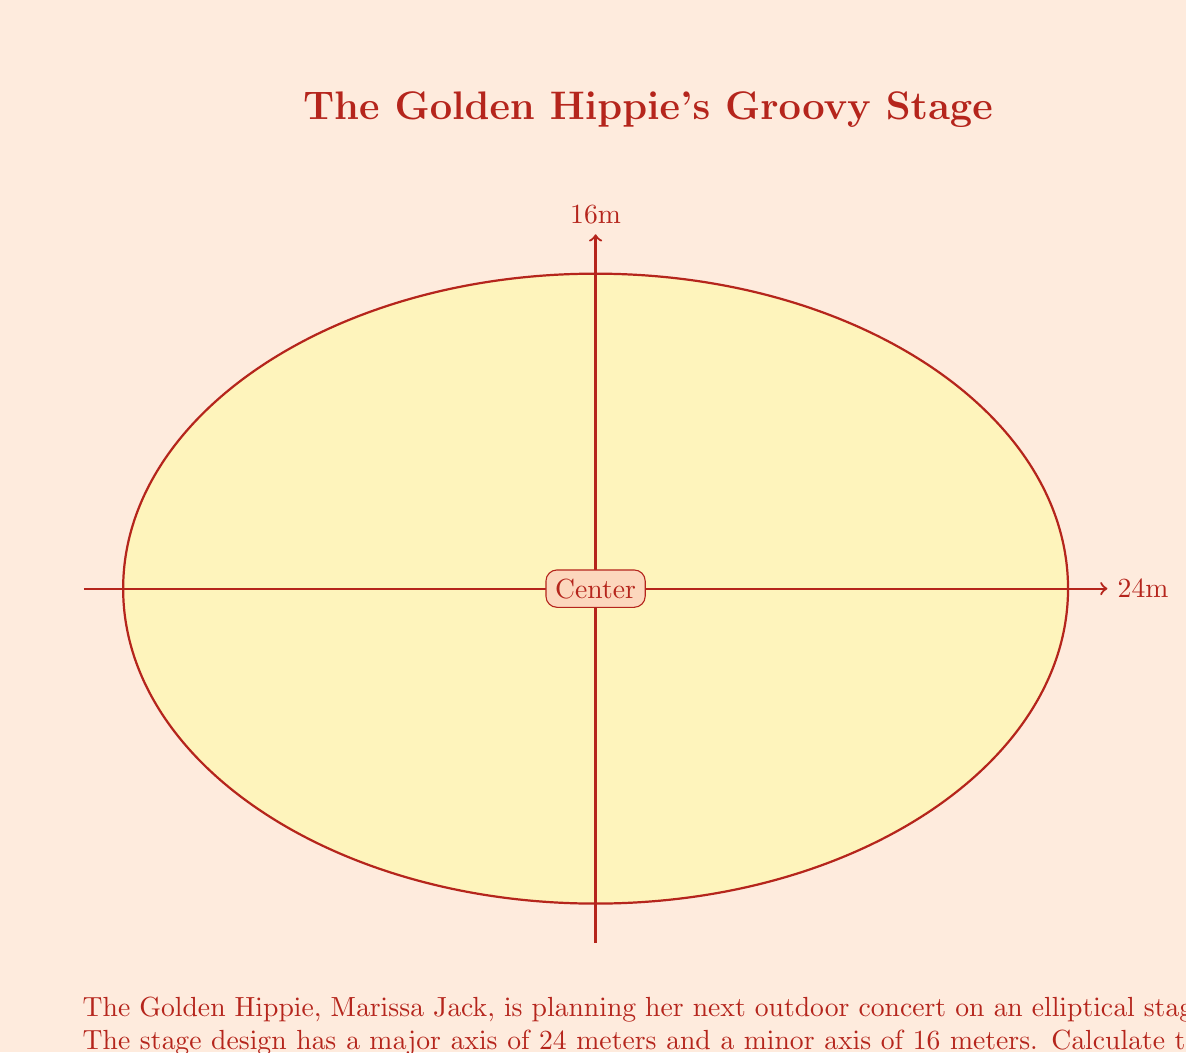Can you answer this question? Let's groove through this calculation step by step:

1) The formula for the area of an ellipse is:

   $$A = \pi ab$$

   where $a$ is half the length of the major axis and $b$ is half the length of the minor axis.

2) From the given dimensions:
   - Major axis = 24 meters, so $a = 24/2 = 12$ meters
   - Minor axis = 16 meters, so $b = 16/2 = 8$ meters

3) Now, let's plug these values into our formula:

   $$A = \pi (12)(8)$$

4) Simplify:
   $$A = 96\pi$$

5) If we want to express this in square meters (to two decimal places):
   $$A \approx 301.59 \text{ m}^2$$

Thus, the area of Marissa Jack's elliptical stage is approximately 301.59 square meters, providing plenty of space for her to spread her golden vibes!
Answer: $301.59 \text{ m}^2$ 